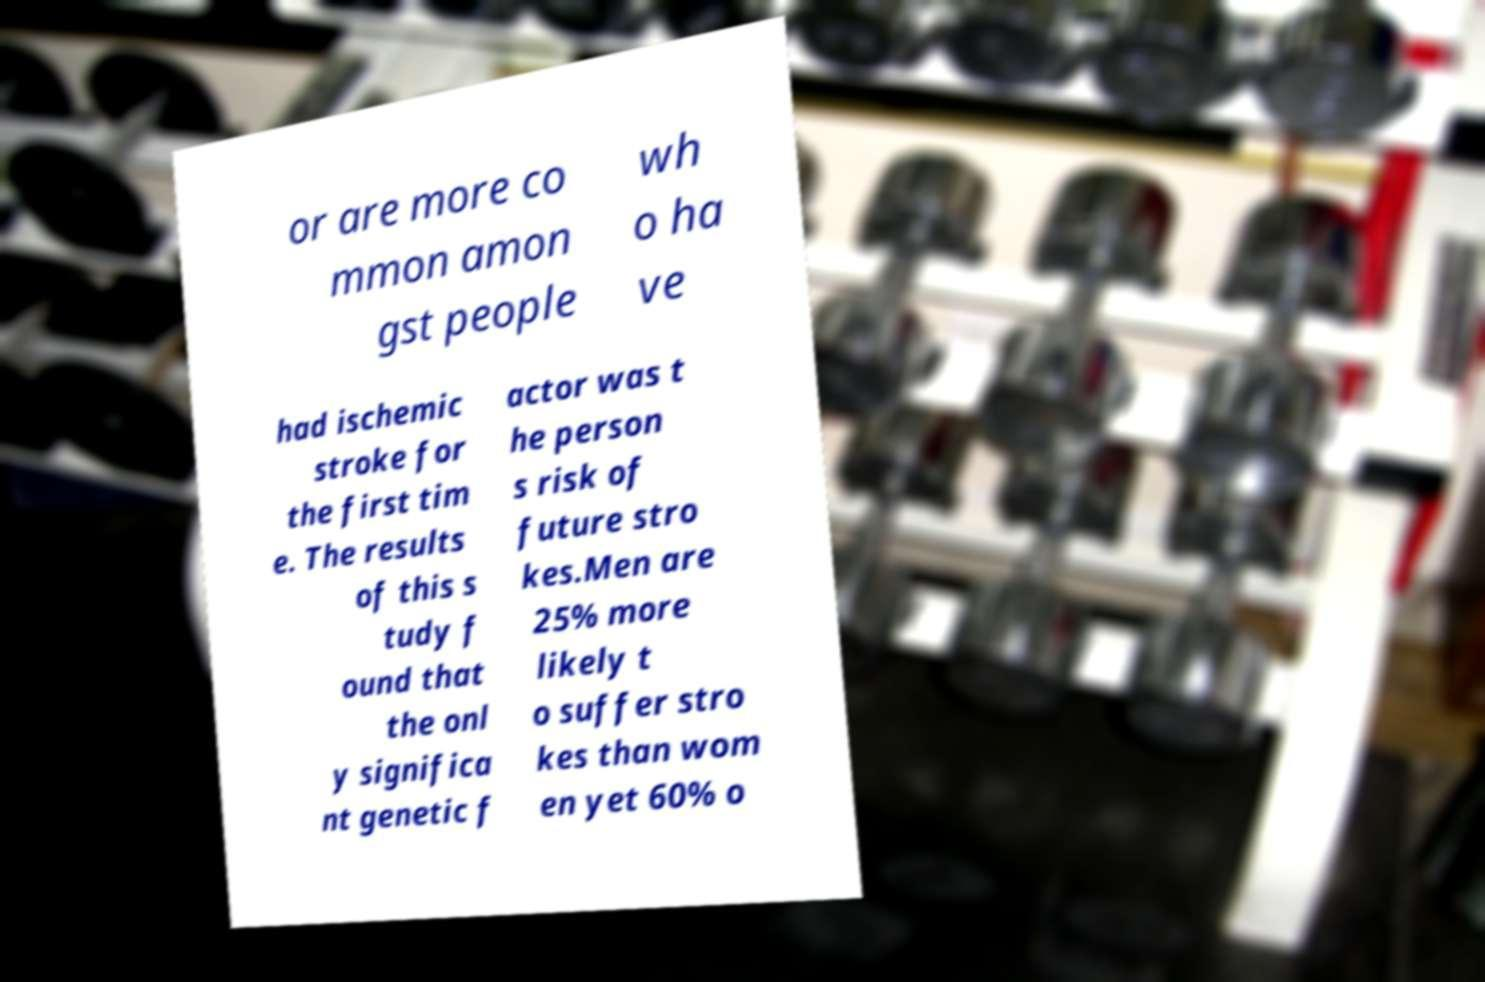Please read and relay the text visible in this image. What does it say? or are more co mmon amon gst people wh o ha ve had ischemic stroke for the first tim e. The results of this s tudy f ound that the onl y significa nt genetic f actor was t he person s risk of future stro kes.Men are 25% more likely t o suffer stro kes than wom en yet 60% o 